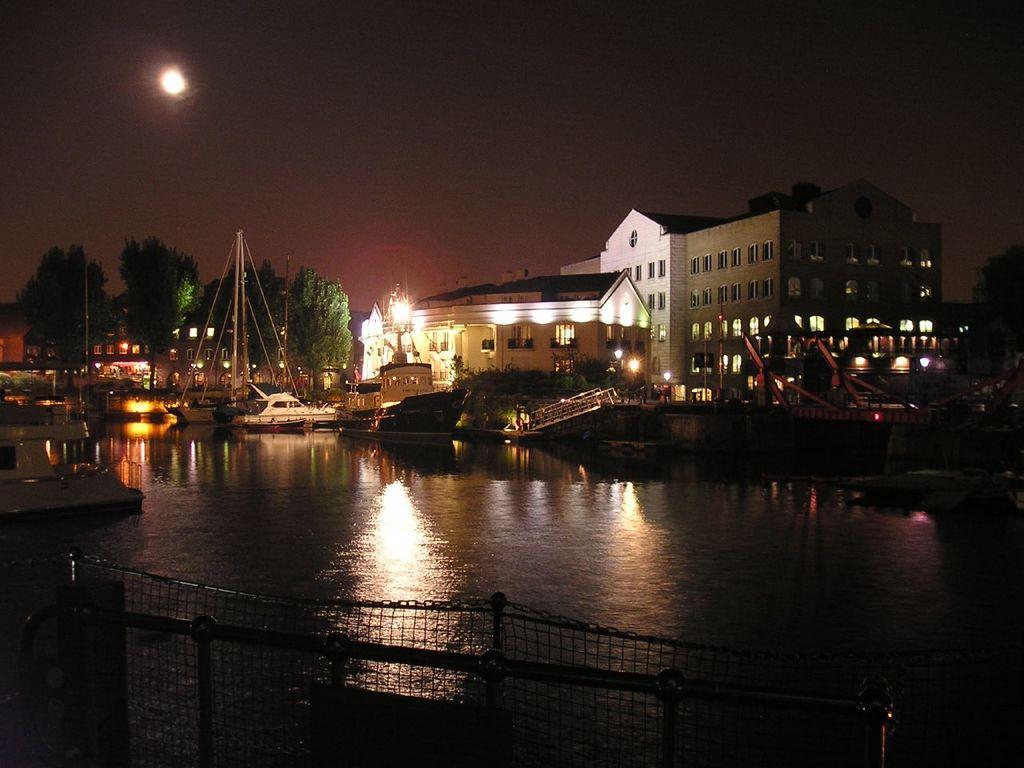In one or two sentences, can you explain what this image depicts? These are the boats on the water. I can see the trees. These are the buildings with the windows and lights. This looks like a bridge. I think this is a fence. This looks like the moon in the sky. 